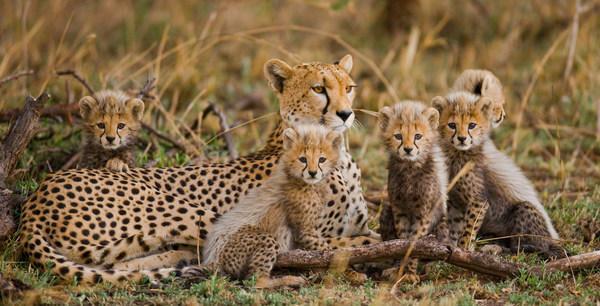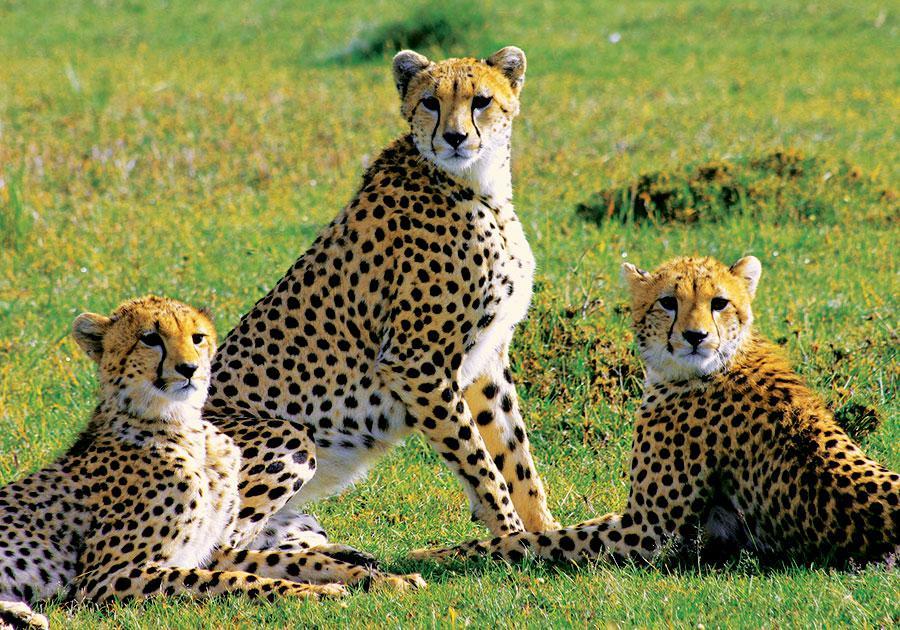The first image is the image on the left, the second image is the image on the right. Assess this claim about the two images: "There are no more than three animals in one of the images.". Correct or not? Answer yes or no. Yes. 